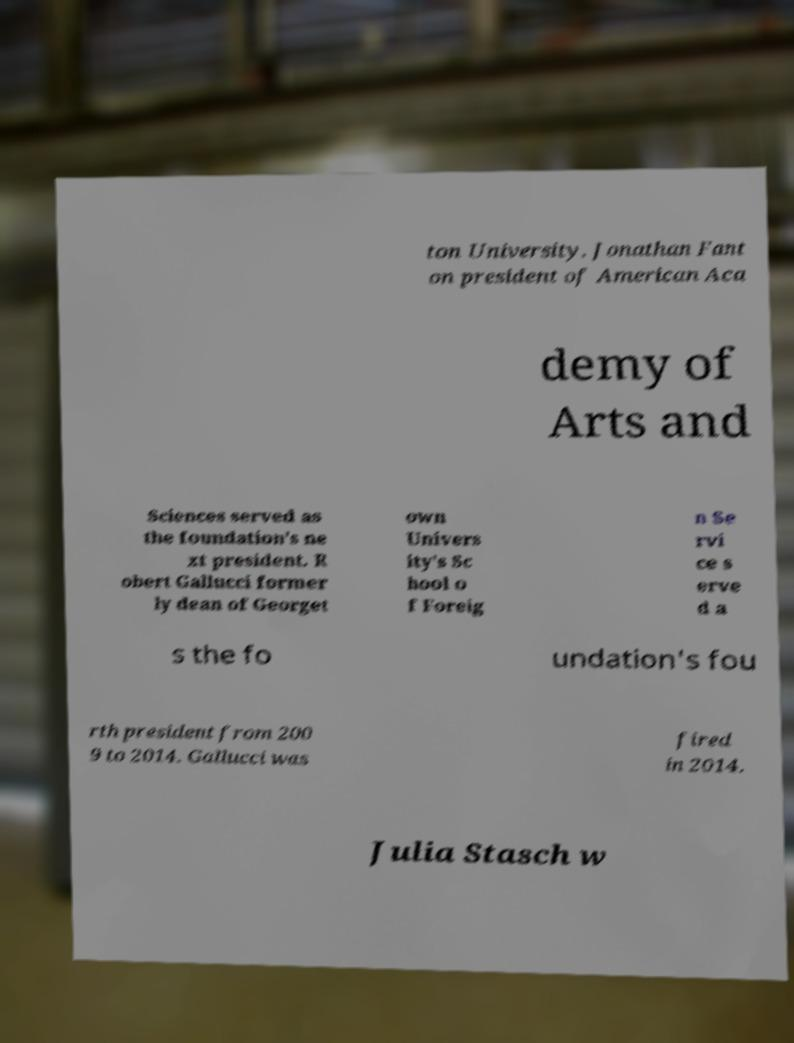Could you extract and type out the text from this image? ton University. Jonathan Fant on president of American Aca demy of Arts and Sciences served as the foundation's ne xt president. R obert Gallucci former ly dean of Georget own Univers ity's Sc hool o f Foreig n Se rvi ce s erve d a s the fo undation's fou rth president from 200 9 to 2014. Gallucci was fired in 2014. Julia Stasch w 